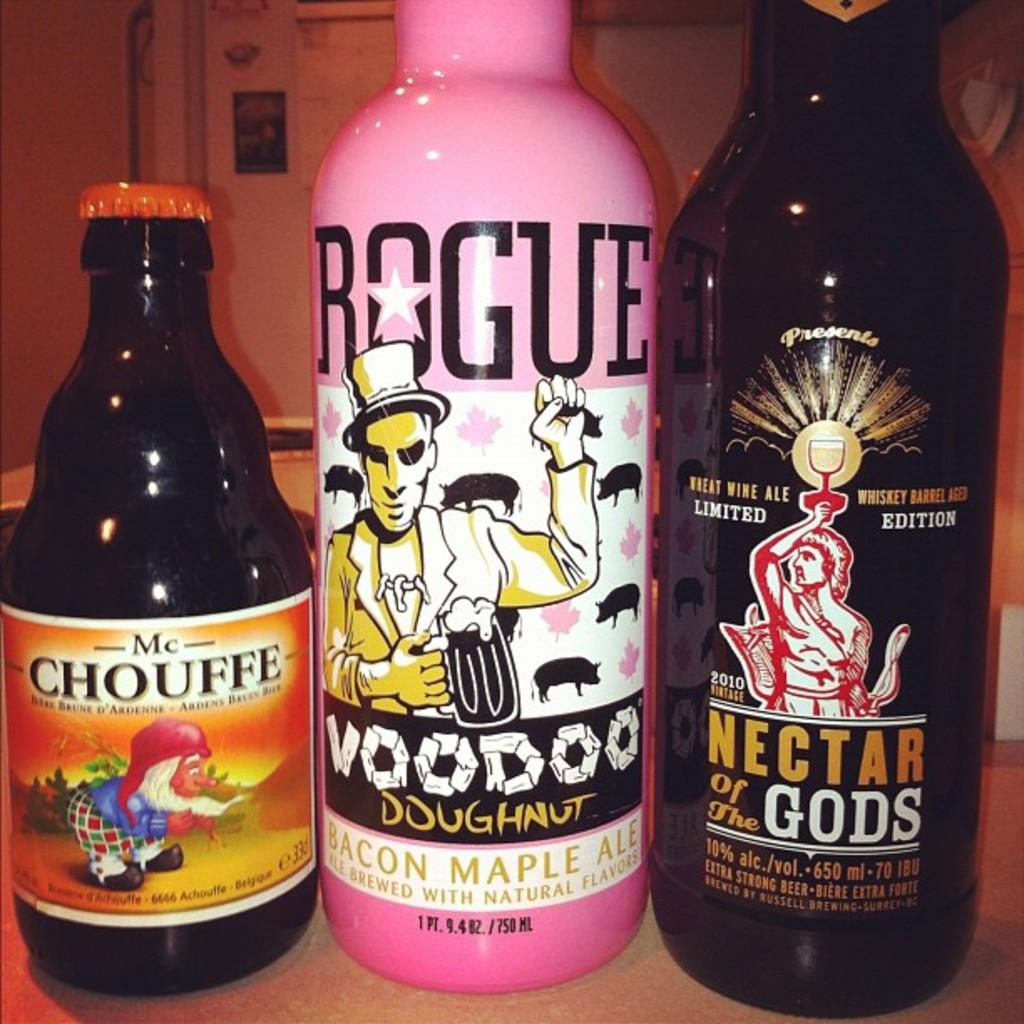What is the brand of the pink bottle?
Offer a terse response. Rogue. 